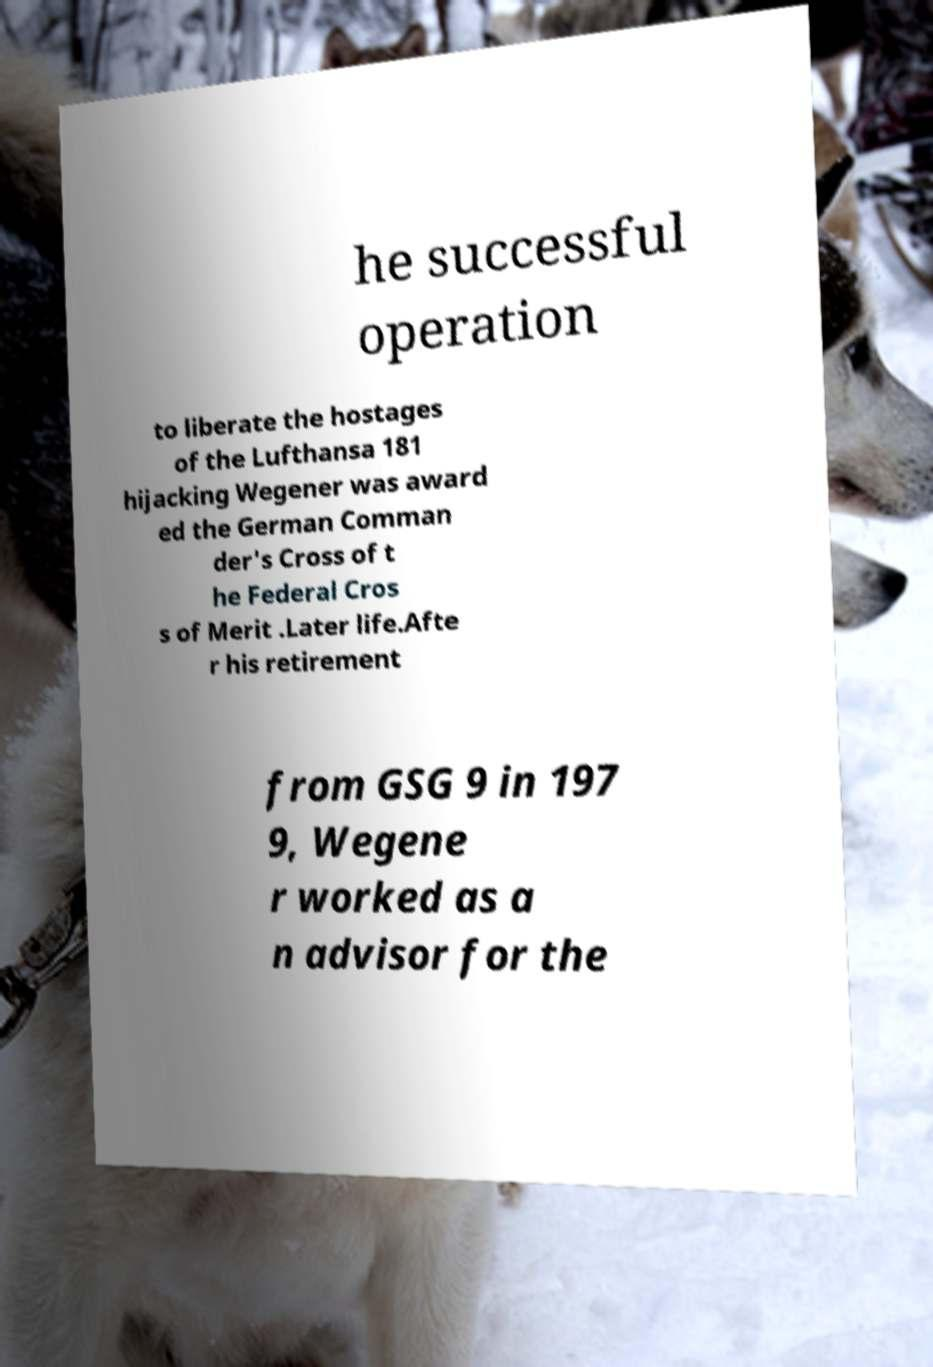I need the written content from this picture converted into text. Can you do that? he successful operation to liberate the hostages of the Lufthansa 181 hijacking Wegener was award ed the German Comman der's Cross of t he Federal Cros s of Merit .Later life.Afte r his retirement from GSG 9 in 197 9, Wegene r worked as a n advisor for the 